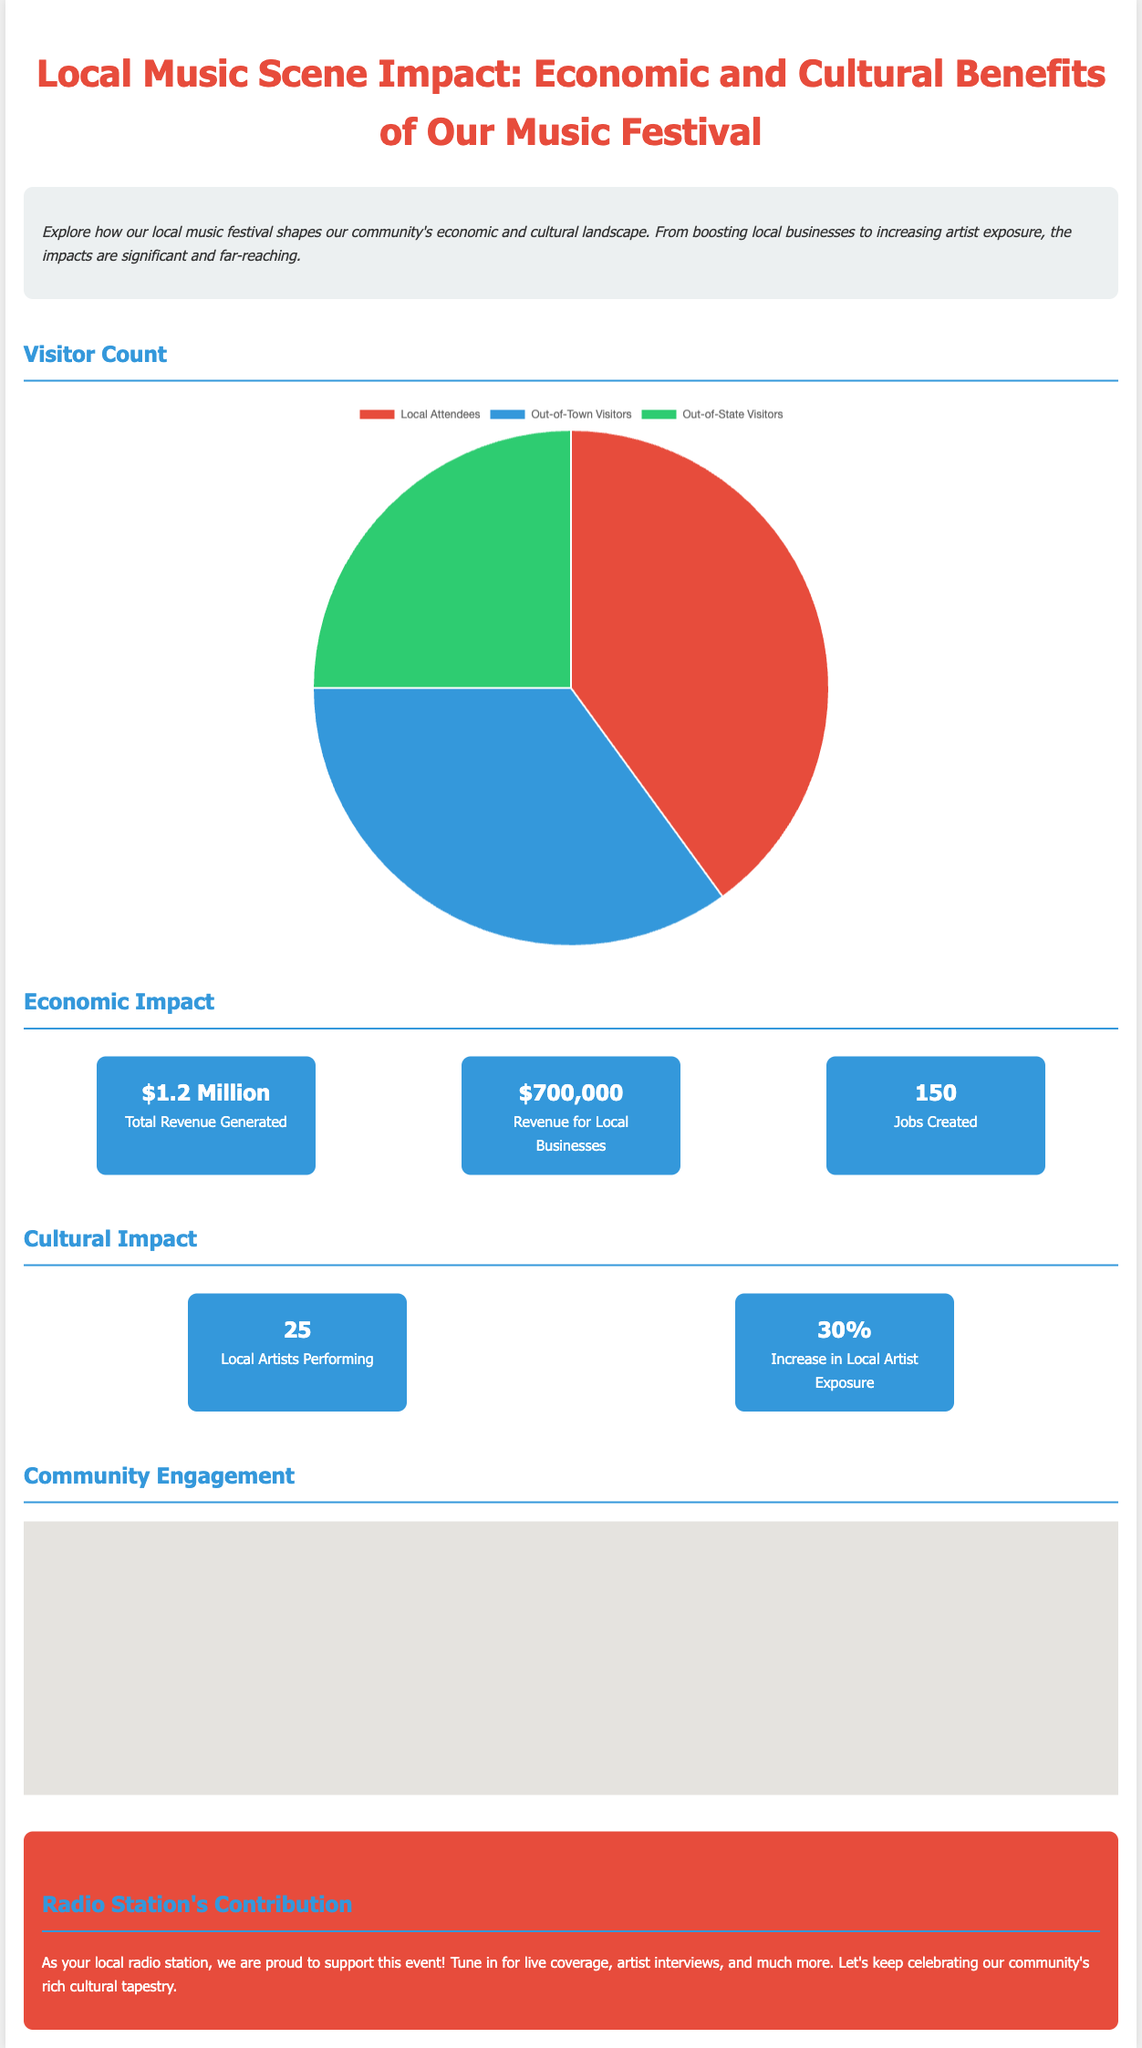What is the total revenue generated? The total revenue generated is highlighted in the economic impact section of the document, which states it is $1.2 Million.
Answer: $1.2 Million How many local artists are performing? The cultural impact section specifies that there are 25 local artists performing at the festival.
Answer: 25 What percentage increase in local artist exposure is mentioned? The document indicates an increase in local artist exposure of 30%, which is shown in the cultural impact section.
Answer: 30% What is the estimated percentage of out-of-town visitors? The visitor chart illustrates that out-of-town visitors make up 35% of the estimated visitor distribution.
Answer: 35% How much revenue is generated for local businesses? According to the economic impact statistics, local businesses generate revenue of $700,000.
Answer: $700,000 How many jobs were created due to the festival? The document lists that 150 jobs were created as a result of the event in the economic impact section.
Answer: 150 What does the radio station contribute to the festival? The radio station's section highlights its role in providing live coverage and promoting the event, emphasizing community support.
Answer: Live coverage and promotion What visual representation is used for visitor distribution? The document features a pie chart to visually represent the estimated visitor distribution by type.
Answer: Pie chart What is the focus of the community engagement section? The community engagement section features a map showing locations related to the festival, enhancing the participant experience.
Answer: Map showing locations 